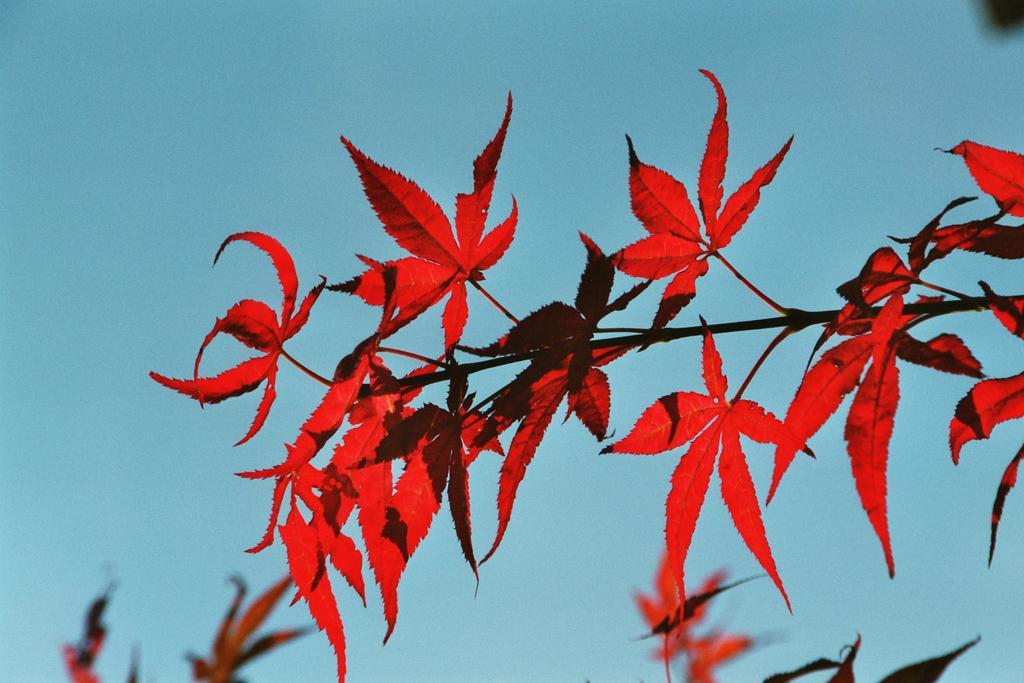Can you describe this image briefly? In this picture I can see there is a plant and it has red color leaves and there are few more leaves in the backdrop and the sky is clear. 